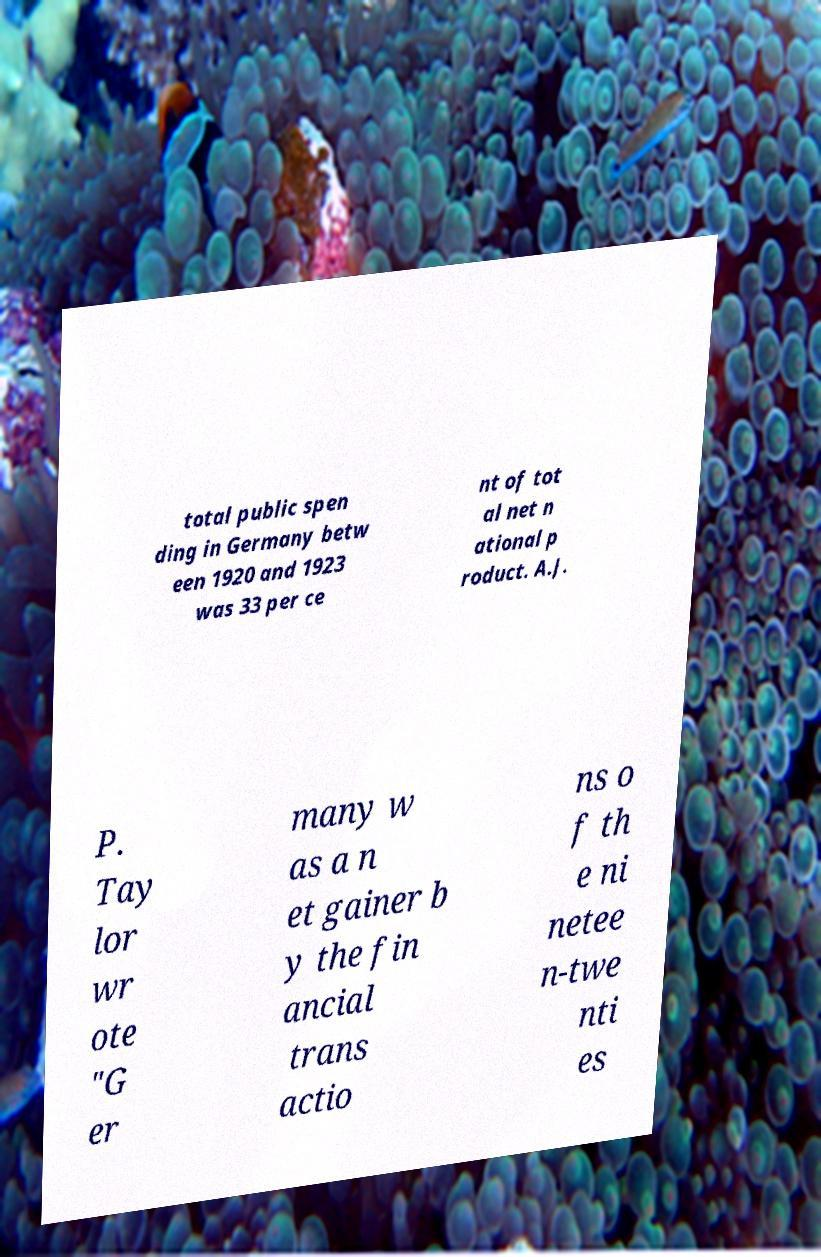Please identify and transcribe the text found in this image. total public spen ding in Germany betw een 1920 and 1923 was 33 per ce nt of tot al net n ational p roduct. A.J. P. Tay lor wr ote "G er many w as a n et gainer b y the fin ancial trans actio ns o f th e ni netee n-twe nti es 